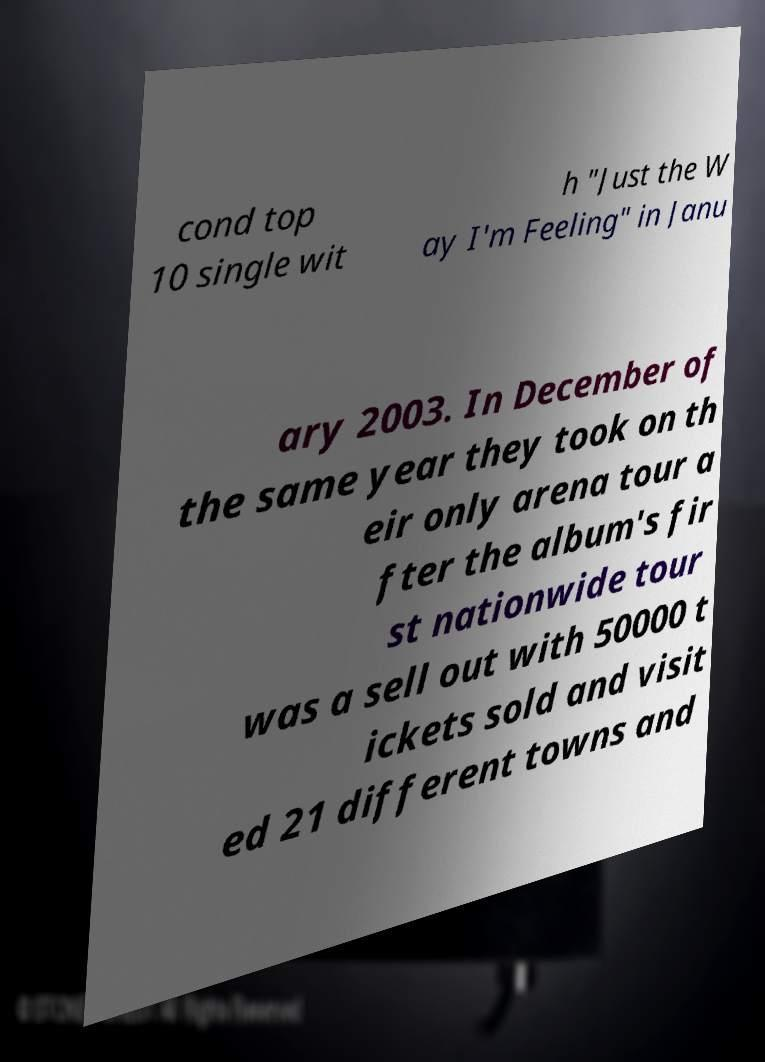Could you assist in decoding the text presented in this image and type it out clearly? cond top 10 single wit h "Just the W ay I'm Feeling" in Janu ary 2003. In December of the same year they took on th eir only arena tour a fter the album's fir st nationwide tour was a sell out with 50000 t ickets sold and visit ed 21 different towns and 